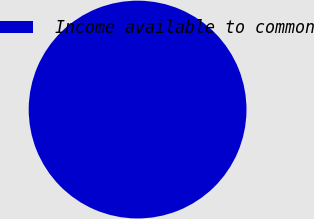Convert chart. <chart><loc_0><loc_0><loc_500><loc_500><pie_chart><fcel>Income available to common<nl><fcel>100.0%<nl></chart> 